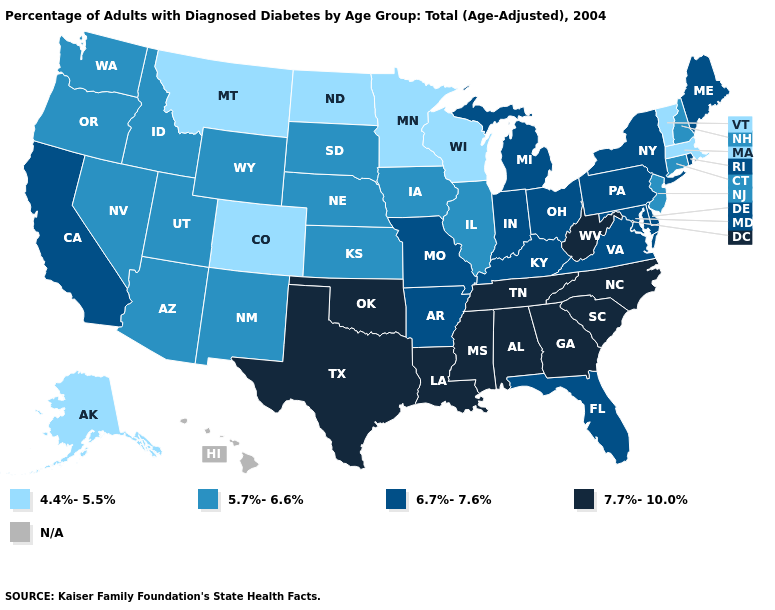What is the lowest value in the Northeast?
Quick response, please. 4.4%-5.5%. Name the states that have a value in the range 7.7%-10.0%?
Quick response, please. Alabama, Georgia, Louisiana, Mississippi, North Carolina, Oklahoma, South Carolina, Tennessee, Texas, West Virginia. Name the states that have a value in the range 6.7%-7.6%?
Short answer required. Arkansas, California, Delaware, Florida, Indiana, Kentucky, Maine, Maryland, Michigan, Missouri, New York, Ohio, Pennsylvania, Rhode Island, Virginia. What is the value of Mississippi?
Give a very brief answer. 7.7%-10.0%. Which states have the lowest value in the USA?
Keep it brief. Alaska, Colorado, Massachusetts, Minnesota, Montana, North Dakota, Vermont, Wisconsin. Does Delaware have the lowest value in the USA?
Answer briefly. No. What is the highest value in states that border Oklahoma?
Keep it brief. 7.7%-10.0%. What is the value of Missouri?
Write a very short answer. 6.7%-7.6%. Does Utah have the lowest value in the USA?
Give a very brief answer. No. Name the states that have a value in the range 6.7%-7.6%?
Give a very brief answer. Arkansas, California, Delaware, Florida, Indiana, Kentucky, Maine, Maryland, Michigan, Missouri, New York, Ohio, Pennsylvania, Rhode Island, Virginia. Name the states that have a value in the range N/A?
Concise answer only. Hawaii. What is the lowest value in states that border Delaware?
Answer briefly. 5.7%-6.6%. What is the value of Tennessee?
Give a very brief answer. 7.7%-10.0%. What is the value of Maine?
Short answer required. 6.7%-7.6%. Does the first symbol in the legend represent the smallest category?
Quick response, please. Yes. 